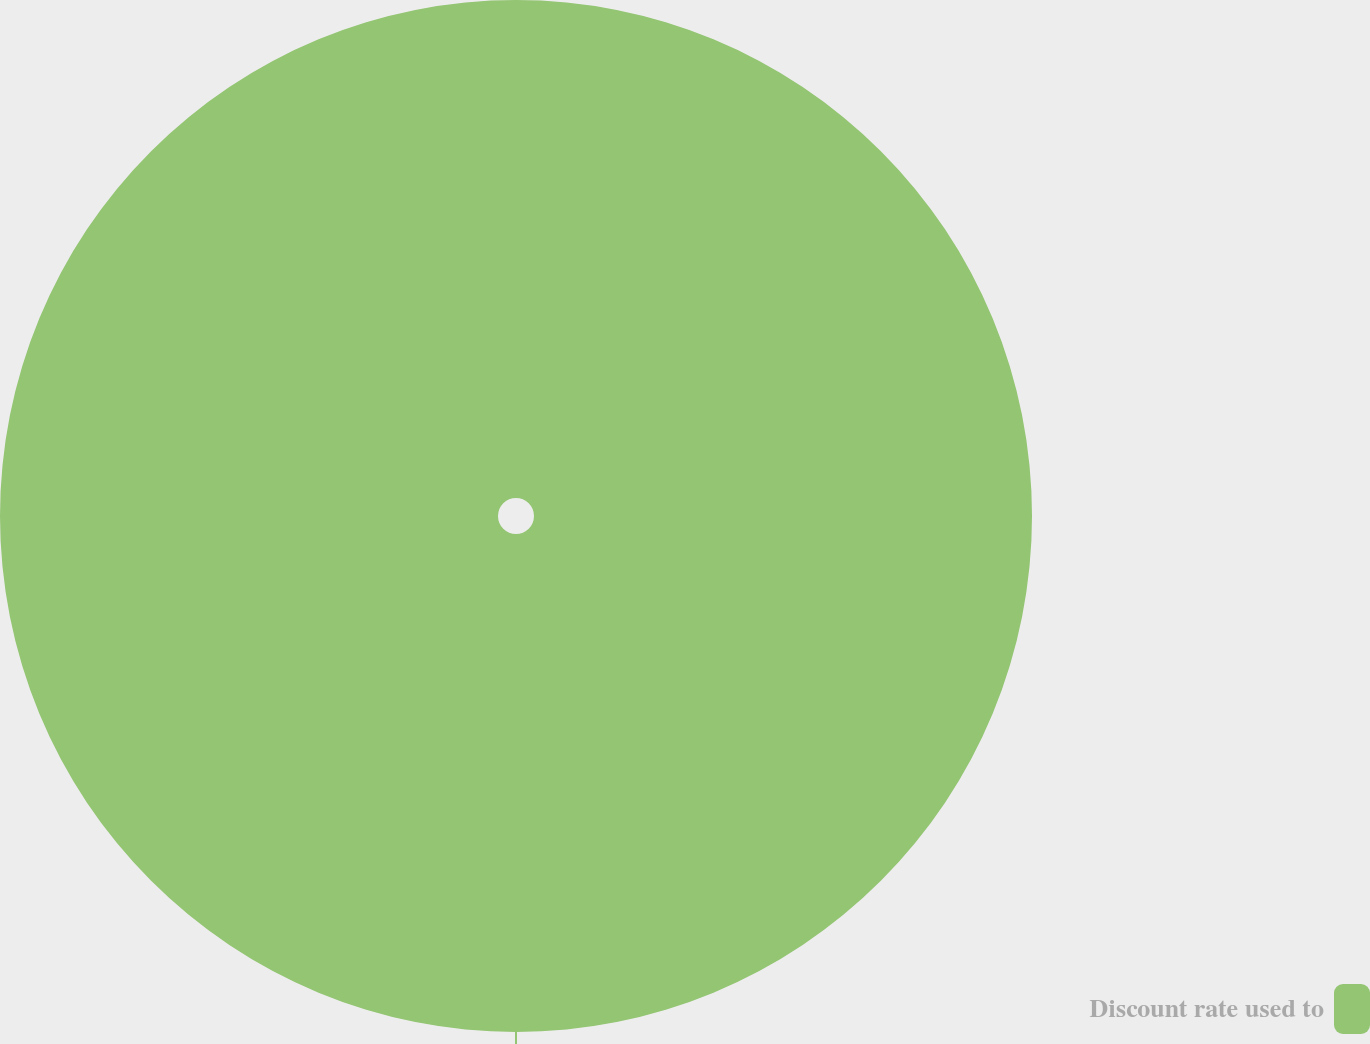<chart> <loc_0><loc_0><loc_500><loc_500><pie_chart><fcel>Discount rate used to<nl><fcel>100.0%<nl></chart> 